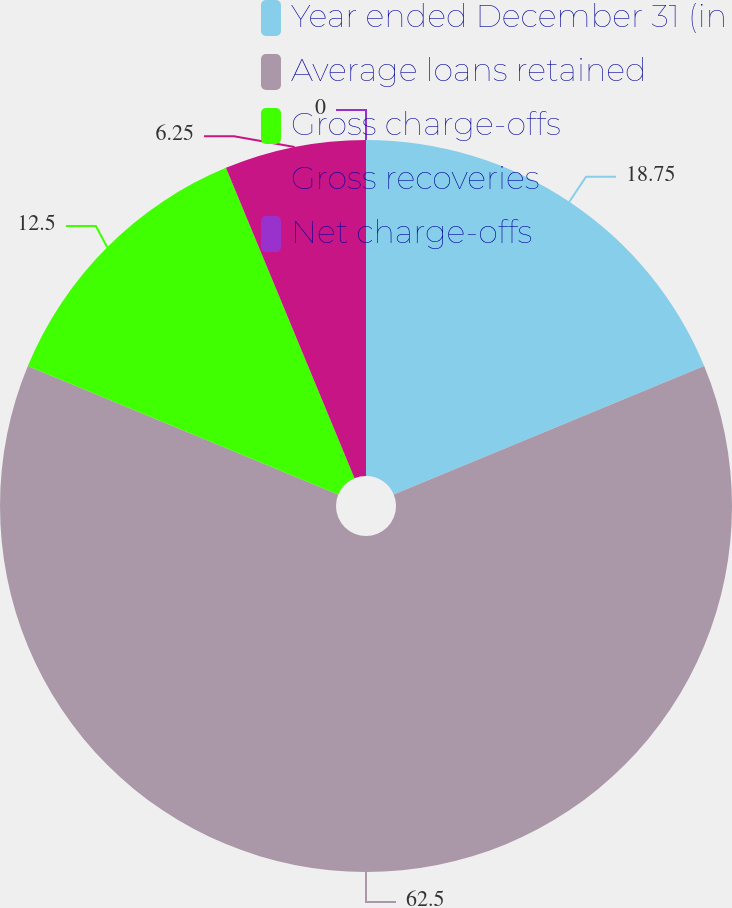Convert chart. <chart><loc_0><loc_0><loc_500><loc_500><pie_chart><fcel>Year ended December 31 (in<fcel>Average loans retained<fcel>Gross charge-offs<fcel>Gross recoveries<fcel>Net charge-offs<nl><fcel>18.75%<fcel>62.49%<fcel>12.5%<fcel>6.25%<fcel>0.0%<nl></chart> 